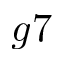<formula> <loc_0><loc_0><loc_500><loc_500>g 7</formula> 